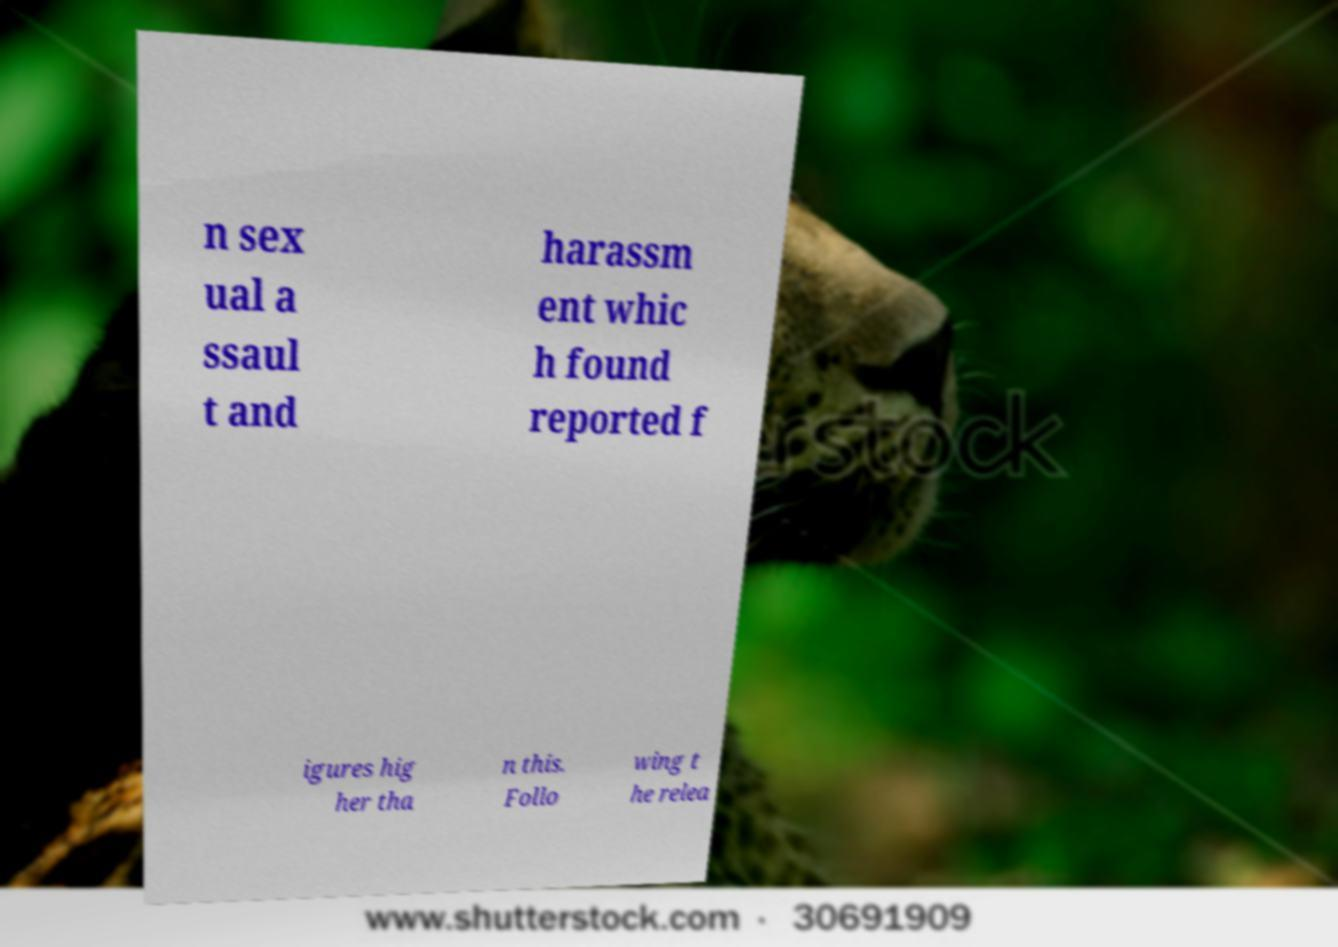Could you extract and type out the text from this image? n sex ual a ssaul t and harassm ent whic h found reported f igures hig her tha n this. Follo wing t he relea 